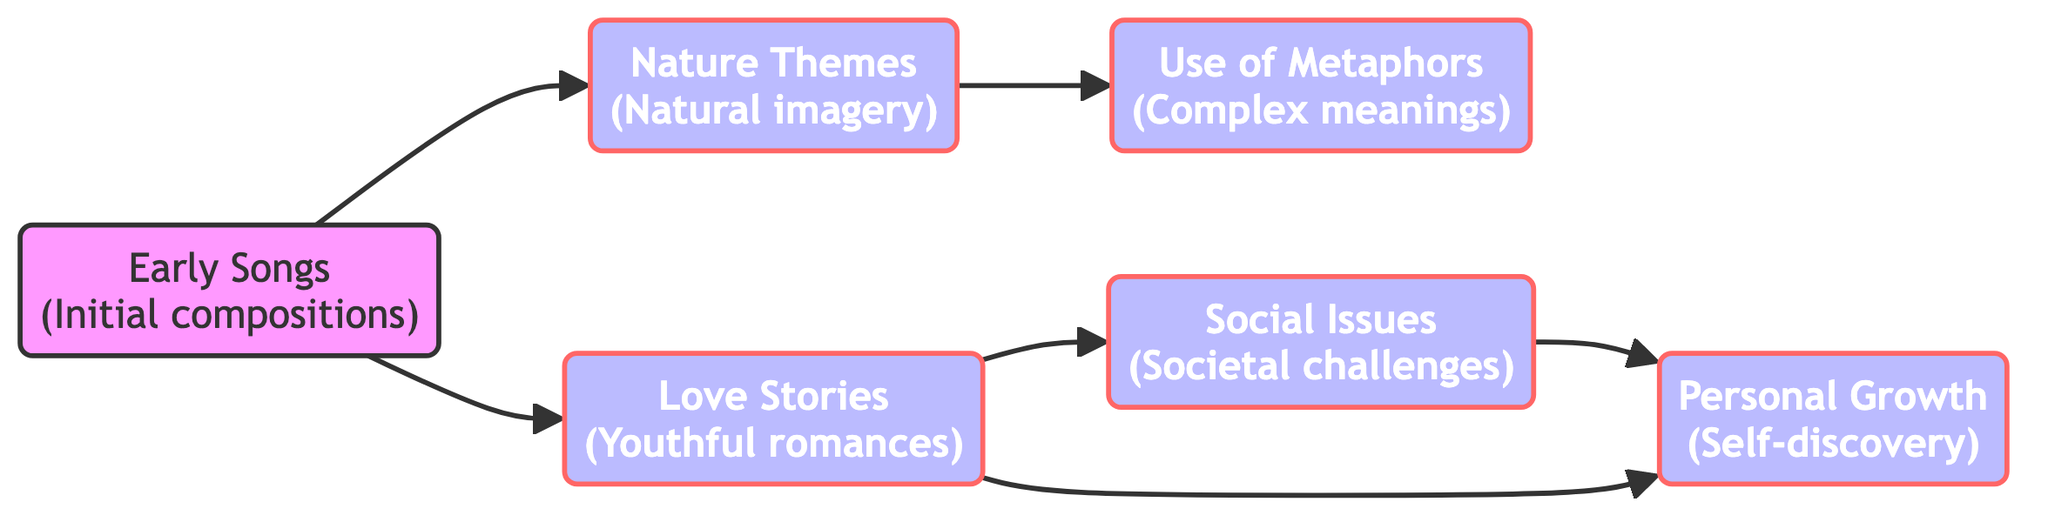What are the initial compositions represented in the diagram? The node labeled "Early Songs" indicates the initial compositions.
Answer: Early Songs How many nodes are present in the diagram? There are six distinct nodes in the diagram representing different storytelling themes.
Answer: 6 What theme connects "Love Stories" and "Social Issues"? The directed edge connecting these two nodes represents a progression from narratives of youthful romances towards addressing societal challenges.
Answer: Love Stories What type of imagery is primarily associated with "Nature Themes"? The description for "Nature Themes" specifies that it is focused on natural imagery.
Answer: Natural imagery Which theme evolves from both "Nature Themes" and "Love Stories"? The edges illustrate that both "Nature Themes" and "Love Stories" lead to the theme of "Personal Growth."
Answer: Personal Growth How many edges are there leading out of "Love Stories"? There are two directed edges leading out of "Love Stories," connecting to "Social Issues" and "Personal Growth."
Answer: 2 What is the relationship between "Nature Themes" and "Metaphors"? The directed edge indicates that "Nature Themes" progresses to "Metaphors," suggesting a development in complexity.
Answer: Metaphors Which themes contribute to the idea of "Personal Growth"? "Love Stories" and "Social Issues" both direct towards "Personal Growth," showing how experiences in those areas contribute to self-discovery.
Answer: Love Stories, Social Issues What does the progression from "Early Songs" to "Love Stories" signify? The directed edge indicates that initial compositions evolve into narratives of youthful romances, reflecting a development in storytelling.
Answer: Love Stories 